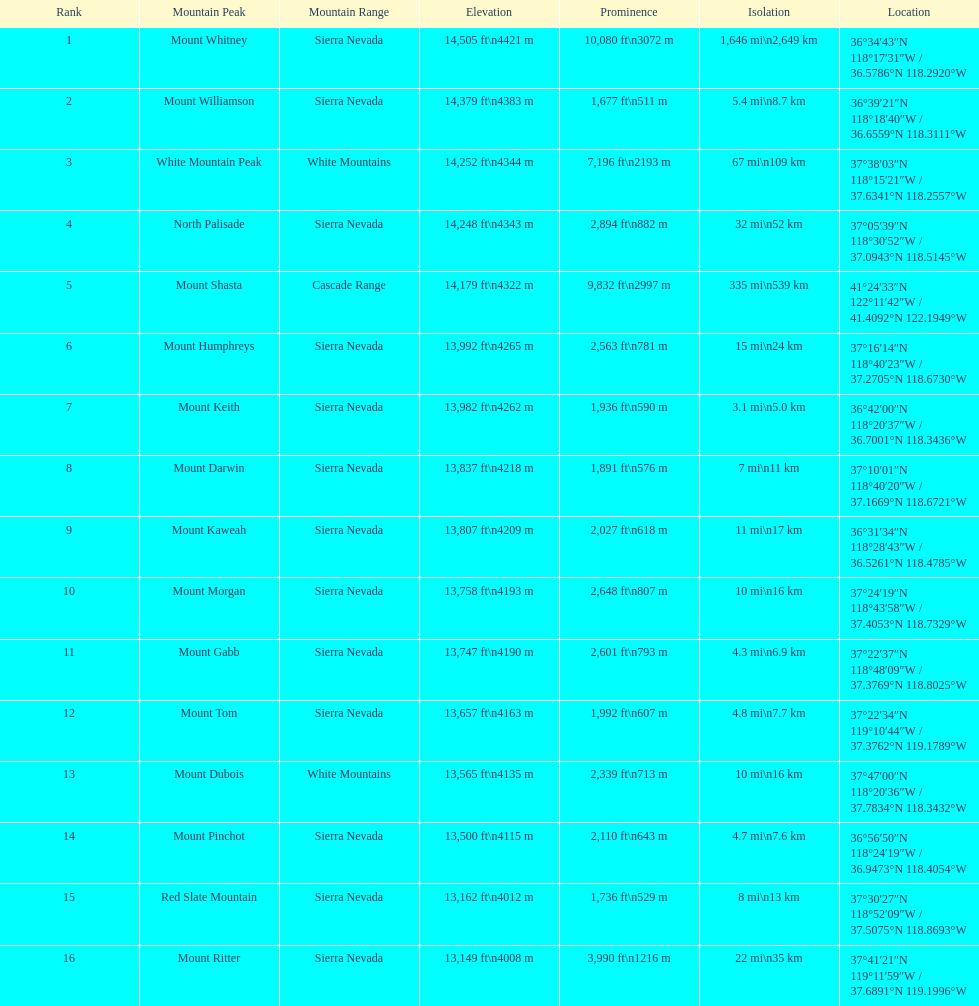Which mountain peak has the least isolation? Mount Keith. 